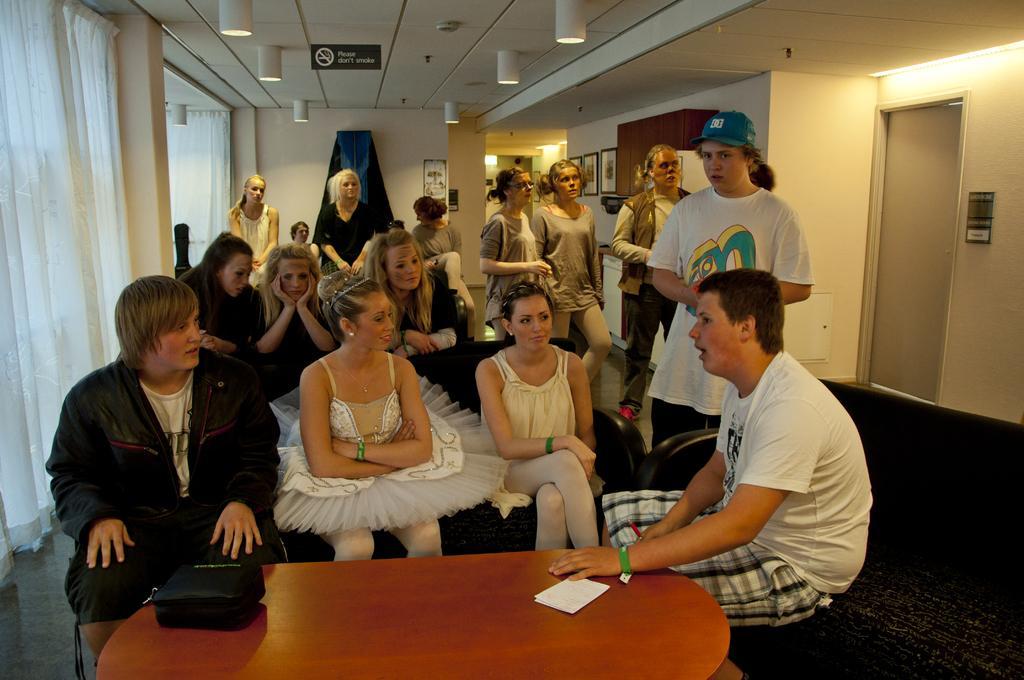Please provide a concise description of this image. This picture is clicked inside the hall. In the foreground we can see the two women wearing white color dresses and sitting on a couch and we can see the two persons sitting on the couch, we can see some objects are placed on the top of the table and we can see the group of persons wearing t-shirts and seems to be standing on the floor. In the background we can see the wall and we can see a person wearing black color dress and standing, we can see the group of persons. At the top there is a roof, lights and we can see the curtains, wall, door, picture frames hanging on the wall, wooden cabinet and some other objects. 